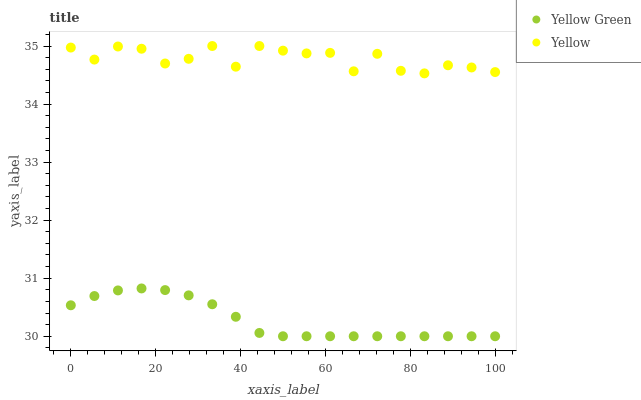Does Yellow Green have the minimum area under the curve?
Answer yes or no. Yes. Does Yellow have the maximum area under the curve?
Answer yes or no. Yes. Does Yellow have the minimum area under the curve?
Answer yes or no. No. Is Yellow Green the smoothest?
Answer yes or no. Yes. Is Yellow the roughest?
Answer yes or no. Yes. Is Yellow the smoothest?
Answer yes or no. No. Does Yellow Green have the lowest value?
Answer yes or no. Yes. Does Yellow have the lowest value?
Answer yes or no. No. Does Yellow have the highest value?
Answer yes or no. Yes. Is Yellow Green less than Yellow?
Answer yes or no. Yes. Is Yellow greater than Yellow Green?
Answer yes or no. Yes. Does Yellow Green intersect Yellow?
Answer yes or no. No. 